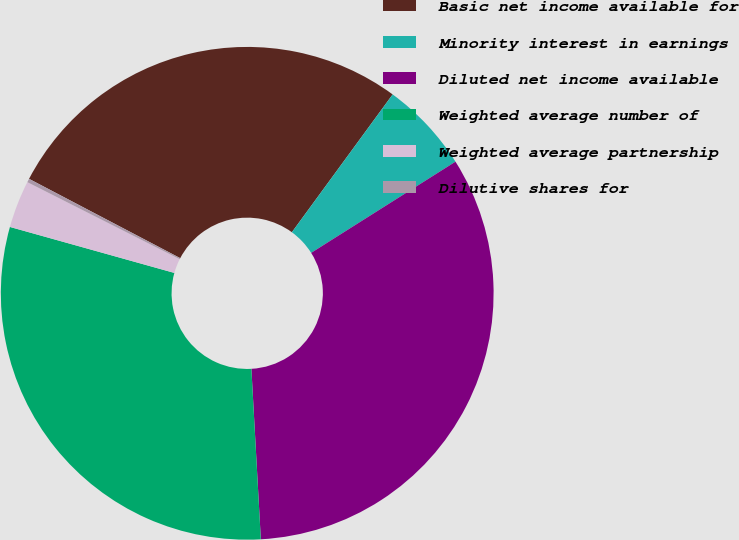Convert chart. <chart><loc_0><loc_0><loc_500><loc_500><pie_chart><fcel>Basic net income available for<fcel>Minority interest in earnings<fcel>Diluted net income available<fcel>Weighted average number of<fcel>Weighted average partnership<fcel>Dilutive shares for<nl><fcel>27.36%<fcel>5.98%<fcel>33.09%<fcel>30.22%<fcel>3.11%<fcel>0.24%<nl></chart> 